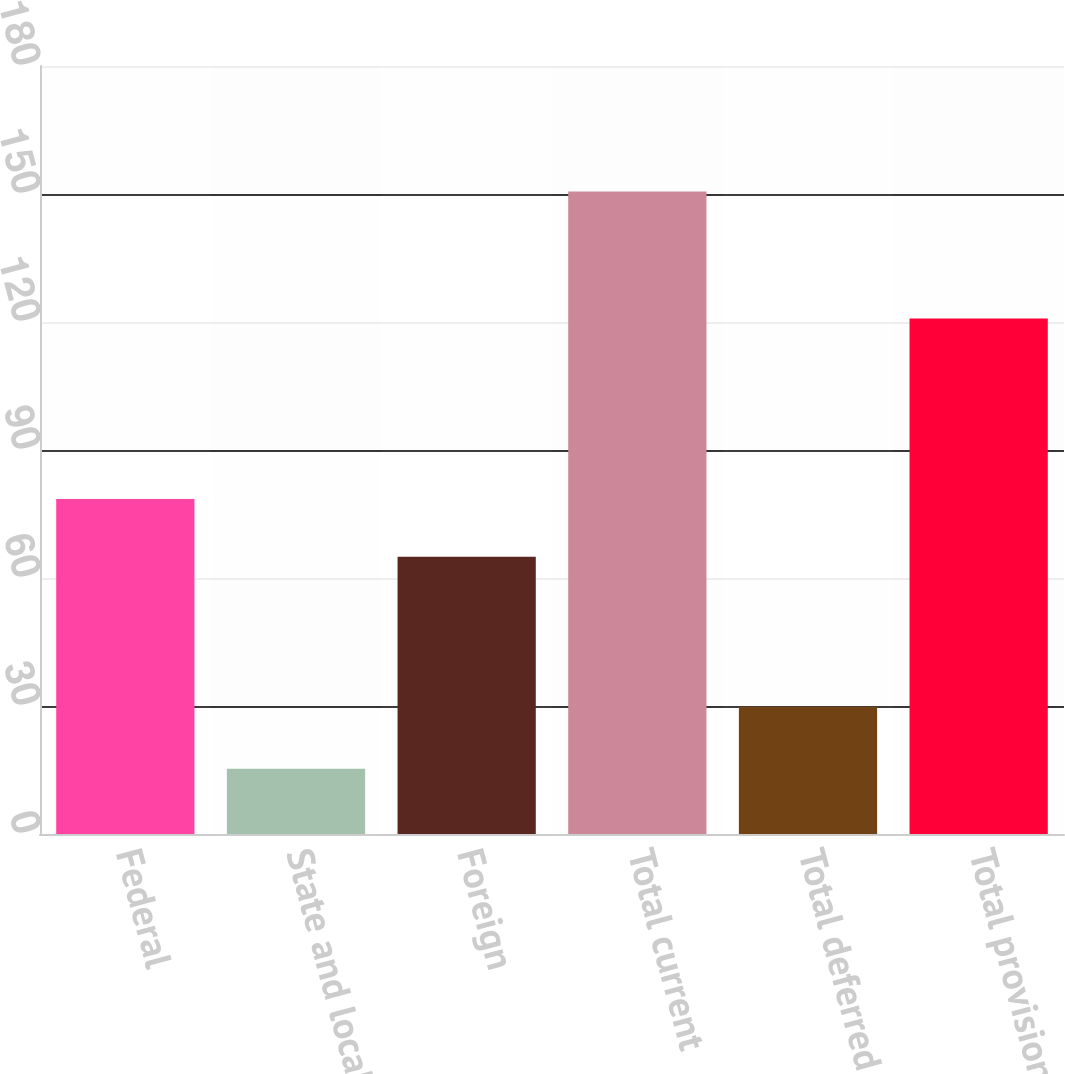Convert chart. <chart><loc_0><loc_0><loc_500><loc_500><bar_chart><fcel>Federal<fcel>State and local<fcel>Foreign<fcel>Total current<fcel>Total deferred<fcel>Total provision<nl><fcel>78.53<fcel>15.3<fcel>65<fcel>150.6<fcel>29.8<fcel>120.8<nl></chart> 